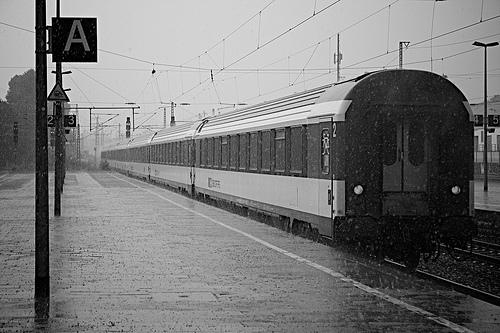Mention three details about the train in the image. The train has round headlights, double doors with oval windows, and ridged lines on its roof. Analyze the visual context of the trees and buildings in the background. The trees and buildings in the background give the impression of an urban setting, with the train passing through in the rain. State two features of the train platform and their characteristics. The train platform is made of bricks and has a wet surface due to rain, with a large white painted line on it. Identify the primary mode of transportation in the image and its condition. A passenger train moving through the city in the rain, with lights on and windows visible. What does the sky and weather in the image seem like? The sky appears to be grey and overcast, suggesting rainy weather conditions. Describe the appearance and state of the train tracks in the image. The train tracks are black metal, appearing wet from rain, and provide a path for the train as it moves along the platform. Explain the purpose of the electrical wiring and grids in the image. The electrical wiring and grids above the train serve as overhead lines for powering the train as it moves along the tracks. What is the overall aesthetic and tonality of the image? The image features a black and white aesthetic, creating a moody, atmospheric tone due to the rainy weather. What role do the numerous poles and wires have in the scene? The poles and wires are part of the train's infrastructure, supporting electrical supply and signage for passengers and the train system. Is the sky filled with colorful balloons and kites? No, it's not mentioned in the image. Is the train on the platform green and covered with graffiti? There is no information about the train's color or any graffiti, and it is mentioned that the photo is black and white. 